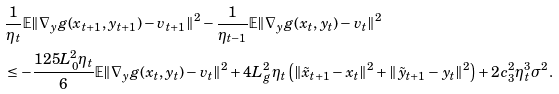<formula> <loc_0><loc_0><loc_500><loc_500>& \frac { 1 } { \eta _ { t } } \mathbb { E } \| \nabla _ { y } g ( x _ { t + 1 } , y _ { t + 1 } ) - v _ { t + 1 } \| ^ { 2 } - \frac { 1 } { \eta _ { t - 1 } } \mathbb { E } \| \nabla _ { y } g ( x _ { t } , y _ { t } ) - v _ { t } \| ^ { 2 } \\ & \leq - \frac { 1 2 5 L ^ { 2 } _ { 0 } \eta _ { t } } { 6 } \mathbb { E } \| \nabla _ { y } g ( x _ { t } , y _ { t } ) - v _ { t } \| ^ { 2 } + 4 L ^ { 2 } _ { g } \eta _ { t } \left ( \| \tilde { x } _ { t + 1 } - x _ { t } \| ^ { 2 } + \| \tilde { y } _ { t + 1 } - y _ { t } \| ^ { 2 } \right ) + 2 c _ { 3 } ^ { 2 } \eta _ { t } ^ { 3 } \sigma ^ { 2 } .</formula> 